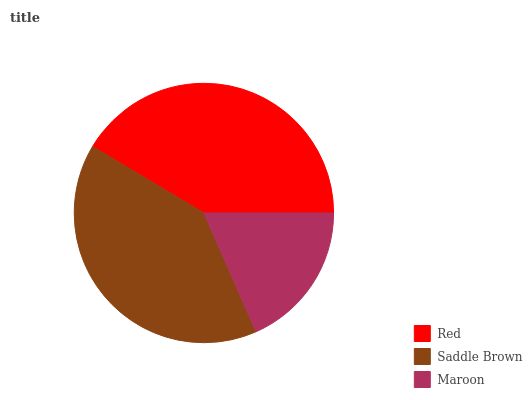Is Maroon the minimum?
Answer yes or no. Yes. Is Red the maximum?
Answer yes or no. Yes. Is Saddle Brown the minimum?
Answer yes or no. No. Is Saddle Brown the maximum?
Answer yes or no. No. Is Red greater than Saddle Brown?
Answer yes or no. Yes. Is Saddle Brown less than Red?
Answer yes or no. Yes. Is Saddle Brown greater than Red?
Answer yes or no. No. Is Red less than Saddle Brown?
Answer yes or no. No. Is Saddle Brown the high median?
Answer yes or no. Yes. Is Saddle Brown the low median?
Answer yes or no. Yes. Is Red the high median?
Answer yes or no. No. Is Red the low median?
Answer yes or no. No. 